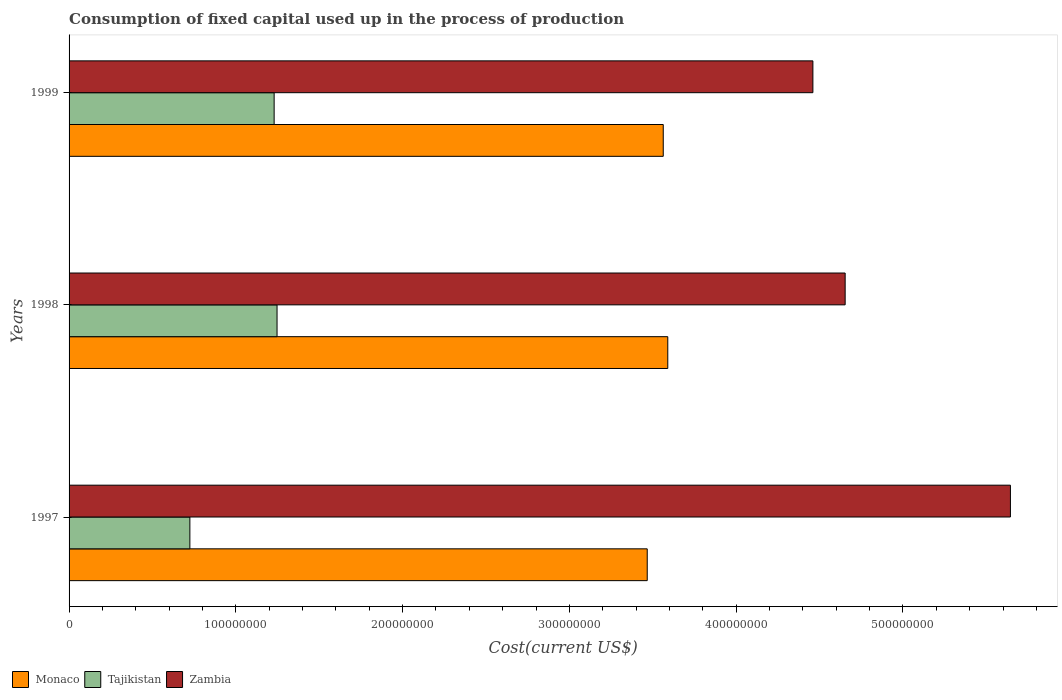How many different coloured bars are there?
Your answer should be compact. 3. Are the number of bars per tick equal to the number of legend labels?
Ensure brevity in your answer.  Yes. What is the label of the 2nd group of bars from the top?
Your answer should be very brief. 1998. In how many cases, is the number of bars for a given year not equal to the number of legend labels?
Offer a terse response. 0. What is the amount consumed in the process of production in Tajikistan in 1999?
Provide a short and direct response. 1.23e+08. Across all years, what is the maximum amount consumed in the process of production in Monaco?
Offer a very short reply. 3.59e+08. Across all years, what is the minimum amount consumed in the process of production in Zambia?
Provide a short and direct response. 4.46e+08. In which year was the amount consumed in the process of production in Monaco maximum?
Offer a very short reply. 1998. In which year was the amount consumed in the process of production in Tajikistan minimum?
Keep it short and to the point. 1997. What is the total amount consumed in the process of production in Tajikistan in the graph?
Offer a terse response. 3.20e+08. What is the difference between the amount consumed in the process of production in Tajikistan in 1998 and that in 1999?
Provide a short and direct response. 1.74e+06. What is the difference between the amount consumed in the process of production in Tajikistan in 1997 and the amount consumed in the process of production in Monaco in 1999?
Offer a terse response. -2.84e+08. What is the average amount consumed in the process of production in Zambia per year?
Keep it short and to the point. 4.92e+08. In the year 1997, what is the difference between the amount consumed in the process of production in Zambia and amount consumed in the process of production in Monaco?
Keep it short and to the point. 2.18e+08. What is the ratio of the amount consumed in the process of production in Monaco in 1997 to that in 1999?
Provide a succinct answer. 0.97. Is the amount consumed in the process of production in Monaco in 1997 less than that in 1999?
Give a very brief answer. Yes. Is the difference between the amount consumed in the process of production in Zambia in 1997 and 1999 greater than the difference between the amount consumed in the process of production in Monaco in 1997 and 1999?
Your answer should be very brief. Yes. What is the difference between the highest and the second highest amount consumed in the process of production in Tajikistan?
Give a very brief answer. 1.74e+06. What is the difference between the highest and the lowest amount consumed in the process of production in Monaco?
Your answer should be very brief. 1.23e+07. In how many years, is the amount consumed in the process of production in Monaco greater than the average amount consumed in the process of production in Monaco taken over all years?
Your response must be concise. 2. Is the sum of the amount consumed in the process of production in Tajikistan in 1997 and 1999 greater than the maximum amount consumed in the process of production in Monaco across all years?
Offer a terse response. No. What does the 3rd bar from the top in 1999 represents?
Keep it short and to the point. Monaco. What does the 2nd bar from the bottom in 1999 represents?
Offer a very short reply. Tajikistan. Is it the case that in every year, the sum of the amount consumed in the process of production in Monaco and amount consumed in the process of production in Zambia is greater than the amount consumed in the process of production in Tajikistan?
Give a very brief answer. Yes. How many bars are there?
Give a very brief answer. 9. Does the graph contain grids?
Offer a terse response. No. How are the legend labels stacked?
Ensure brevity in your answer.  Horizontal. What is the title of the graph?
Your response must be concise. Consumption of fixed capital used up in the process of production. Does "Europe(developing only)" appear as one of the legend labels in the graph?
Give a very brief answer. No. What is the label or title of the X-axis?
Your answer should be compact. Cost(current US$). What is the label or title of the Y-axis?
Your answer should be very brief. Years. What is the Cost(current US$) in Monaco in 1997?
Give a very brief answer. 3.47e+08. What is the Cost(current US$) of Tajikistan in 1997?
Offer a very short reply. 7.24e+07. What is the Cost(current US$) of Zambia in 1997?
Provide a short and direct response. 5.64e+08. What is the Cost(current US$) of Monaco in 1998?
Keep it short and to the point. 3.59e+08. What is the Cost(current US$) of Tajikistan in 1998?
Your response must be concise. 1.25e+08. What is the Cost(current US$) in Zambia in 1998?
Ensure brevity in your answer.  4.65e+08. What is the Cost(current US$) of Monaco in 1999?
Make the answer very short. 3.56e+08. What is the Cost(current US$) of Tajikistan in 1999?
Keep it short and to the point. 1.23e+08. What is the Cost(current US$) of Zambia in 1999?
Keep it short and to the point. 4.46e+08. Across all years, what is the maximum Cost(current US$) of Monaco?
Your response must be concise. 3.59e+08. Across all years, what is the maximum Cost(current US$) of Tajikistan?
Give a very brief answer. 1.25e+08. Across all years, what is the maximum Cost(current US$) of Zambia?
Your answer should be very brief. 5.64e+08. Across all years, what is the minimum Cost(current US$) of Monaco?
Offer a terse response. 3.47e+08. Across all years, what is the minimum Cost(current US$) in Tajikistan?
Offer a very short reply. 7.24e+07. Across all years, what is the minimum Cost(current US$) in Zambia?
Provide a succinct answer. 4.46e+08. What is the total Cost(current US$) of Monaco in the graph?
Give a very brief answer. 1.06e+09. What is the total Cost(current US$) of Tajikistan in the graph?
Give a very brief answer. 3.20e+08. What is the total Cost(current US$) in Zambia in the graph?
Make the answer very short. 1.48e+09. What is the difference between the Cost(current US$) of Monaco in 1997 and that in 1998?
Offer a very short reply. -1.23e+07. What is the difference between the Cost(current US$) in Tajikistan in 1997 and that in 1998?
Your response must be concise. -5.23e+07. What is the difference between the Cost(current US$) of Zambia in 1997 and that in 1998?
Make the answer very short. 9.91e+07. What is the difference between the Cost(current US$) in Monaco in 1997 and that in 1999?
Your response must be concise. -9.60e+06. What is the difference between the Cost(current US$) in Tajikistan in 1997 and that in 1999?
Your response must be concise. -5.05e+07. What is the difference between the Cost(current US$) of Zambia in 1997 and that in 1999?
Your answer should be very brief. 1.18e+08. What is the difference between the Cost(current US$) in Monaco in 1998 and that in 1999?
Provide a short and direct response. 2.71e+06. What is the difference between the Cost(current US$) in Tajikistan in 1998 and that in 1999?
Provide a short and direct response. 1.74e+06. What is the difference between the Cost(current US$) in Zambia in 1998 and that in 1999?
Your answer should be compact. 1.93e+07. What is the difference between the Cost(current US$) of Monaco in 1997 and the Cost(current US$) of Tajikistan in 1998?
Provide a succinct answer. 2.22e+08. What is the difference between the Cost(current US$) of Monaco in 1997 and the Cost(current US$) of Zambia in 1998?
Offer a terse response. -1.19e+08. What is the difference between the Cost(current US$) of Tajikistan in 1997 and the Cost(current US$) of Zambia in 1998?
Your answer should be compact. -3.93e+08. What is the difference between the Cost(current US$) of Monaco in 1997 and the Cost(current US$) of Tajikistan in 1999?
Your answer should be compact. 2.24e+08. What is the difference between the Cost(current US$) of Monaco in 1997 and the Cost(current US$) of Zambia in 1999?
Provide a succinct answer. -9.93e+07. What is the difference between the Cost(current US$) in Tajikistan in 1997 and the Cost(current US$) in Zambia in 1999?
Keep it short and to the point. -3.74e+08. What is the difference between the Cost(current US$) in Monaco in 1998 and the Cost(current US$) in Tajikistan in 1999?
Provide a short and direct response. 2.36e+08. What is the difference between the Cost(current US$) in Monaco in 1998 and the Cost(current US$) in Zambia in 1999?
Make the answer very short. -8.70e+07. What is the difference between the Cost(current US$) in Tajikistan in 1998 and the Cost(current US$) in Zambia in 1999?
Keep it short and to the point. -3.21e+08. What is the average Cost(current US$) in Monaco per year?
Provide a succinct answer. 3.54e+08. What is the average Cost(current US$) of Tajikistan per year?
Offer a terse response. 1.07e+08. What is the average Cost(current US$) of Zambia per year?
Your response must be concise. 4.92e+08. In the year 1997, what is the difference between the Cost(current US$) of Monaco and Cost(current US$) of Tajikistan?
Keep it short and to the point. 2.74e+08. In the year 1997, what is the difference between the Cost(current US$) of Monaco and Cost(current US$) of Zambia?
Offer a very short reply. -2.18e+08. In the year 1997, what is the difference between the Cost(current US$) of Tajikistan and Cost(current US$) of Zambia?
Make the answer very short. -4.92e+08. In the year 1998, what is the difference between the Cost(current US$) of Monaco and Cost(current US$) of Tajikistan?
Offer a very short reply. 2.34e+08. In the year 1998, what is the difference between the Cost(current US$) in Monaco and Cost(current US$) in Zambia?
Make the answer very short. -1.06e+08. In the year 1998, what is the difference between the Cost(current US$) in Tajikistan and Cost(current US$) in Zambia?
Provide a short and direct response. -3.41e+08. In the year 1999, what is the difference between the Cost(current US$) in Monaco and Cost(current US$) in Tajikistan?
Give a very brief answer. 2.33e+08. In the year 1999, what is the difference between the Cost(current US$) of Monaco and Cost(current US$) of Zambia?
Ensure brevity in your answer.  -8.97e+07. In the year 1999, what is the difference between the Cost(current US$) in Tajikistan and Cost(current US$) in Zambia?
Offer a very short reply. -3.23e+08. What is the ratio of the Cost(current US$) in Monaco in 1997 to that in 1998?
Provide a succinct answer. 0.97. What is the ratio of the Cost(current US$) of Tajikistan in 1997 to that in 1998?
Your answer should be very brief. 0.58. What is the ratio of the Cost(current US$) of Zambia in 1997 to that in 1998?
Offer a terse response. 1.21. What is the ratio of the Cost(current US$) of Monaco in 1997 to that in 1999?
Offer a terse response. 0.97. What is the ratio of the Cost(current US$) of Tajikistan in 1997 to that in 1999?
Make the answer very short. 0.59. What is the ratio of the Cost(current US$) in Zambia in 1997 to that in 1999?
Offer a terse response. 1.27. What is the ratio of the Cost(current US$) of Monaco in 1998 to that in 1999?
Make the answer very short. 1.01. What is the ratio of the Cost(current US$) in Tajikistan in 1998 to that in 1999?
Provide a succinct answer. 1.01. What is the ratio of the Cost(current US$) of Zambia in 1998 to that in 1999?
Provide a short and direct response. 1.04. What is the difference between the highest and the second highest Cost(current US$) of Monaco?
Offer a very short reply. 2.71e+06. What is the difference between the highest and the second highest Cost(current US$) in Tajikistan?
Your answer should be compact. 1.74e+06. What is the difference between the highest and the second highest Cost(current US$) of Zambia?
Offer a terse response. 9.91e+07. What is the difference between the highest and the lowest Cost(current US$) of Monaco?
Ensure brevity in your answer.  1.23e+07. What is the difference between the highest and the lowest Cost(current US$) of Tajikistan?
Provide a succinct answer. 5.23e+07. What is the difference between the highest and the lowest Cost(current US$) in Zambia?
Offer a very short reply. 1.18e+08. 